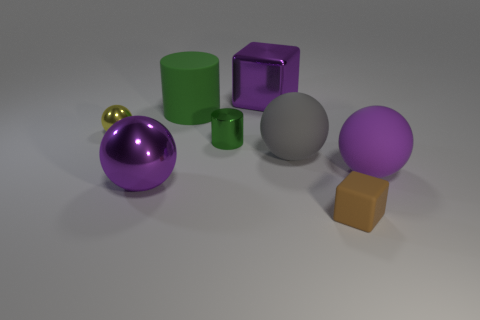Add 1 large gray cubes. How many objects exist? 9 Subtract all cylinders. How many objects are left? 6 Subtract 1 yellow spheres. How many objects are left? 7 Subtract all large blue matte things. Subtract all purple shiny cubes. How many objects are left? 7 Add 4 spheres. How many spheres are left? 8 Add 1 large brown metal spheres. How many large brown metal spheres exist? 1 